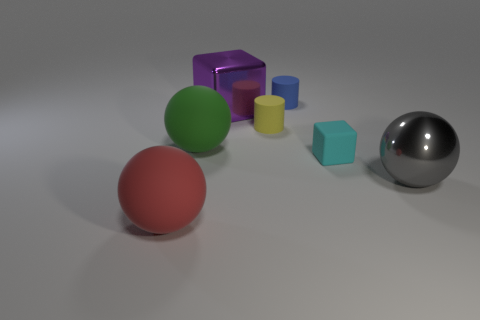Subtract all gray spheres. How many spheres are left? 2 Subtract all green balls. How many balls are left? 2 Subtract 1 cubes. How many cubes are left? 1 Subtract all gray balls. Subtract all purple blocks. How many balls are left? 2 Subtract all green blocks. How many red cylinders are left? 0 Subtract all big purple metal spheres. Subtract all rubber things. How many objects are left? 2 Add 2 cyan things. How many cyan things are left? 3 Add 4 large purple objects. How many large purple objects exist? 5 Add 1 large brown metallic balls. How many objects exist? 8 Subtract 0 cyan cylinders. How many objects are left? 7 